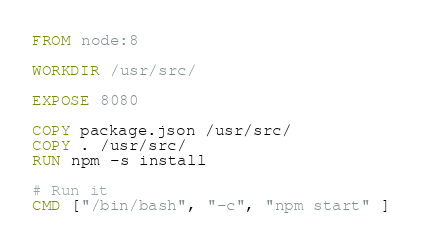<code> <loc_0><loc_0><loc_500><loc_500><_Dockerfile_>FROM node:8

WORKDIR /usr/src/

EXPOSE 8080

COPY package.json /usr/src/
COPY . /usr/src/
RUN npm -s install

# Run it
CMD ["/bin/bash", "-c", "npm start" ]
</code> 